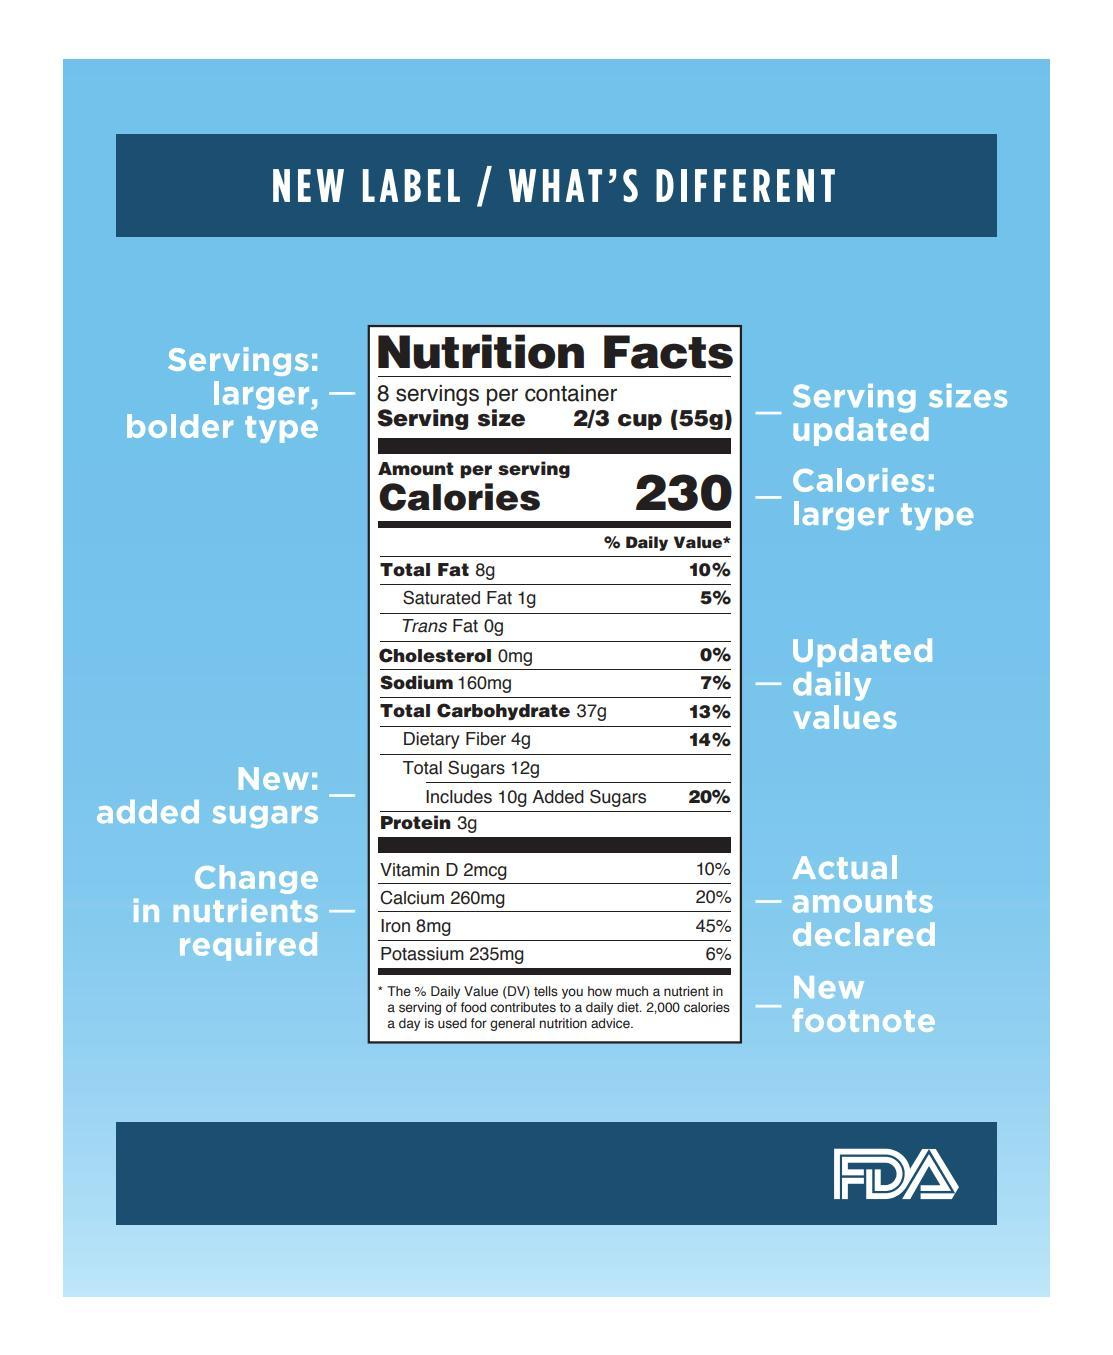What change has been made in the percentages of vitamins, calcium, iron and other nutrients?
Answer the question with a short phrase. actual amounts declared What has been included at the end of the new food nutrition label? new footnote What is mentioned in larger, bolder type in the new label? Servings What changes have been made to the values of cholesterol, sodium, carbohydrates etc.? updated daily values 